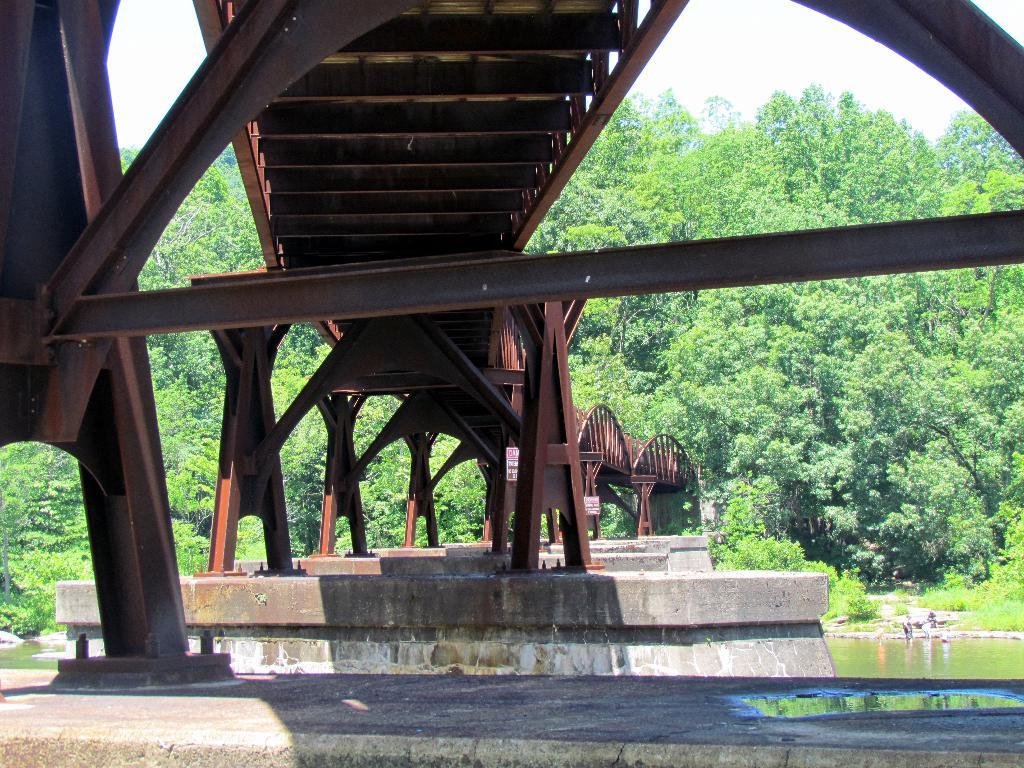What structure is the main subject of the image? There is a bridge in the image. What is the bridge positioned over? The bridge is over water. What can be seen in the background of the image? There are trees visible in the background of the image. What type of berry is growing on the bridge in the image? There are no berries present on the bridge in the image. What type of grain can be seen being harvested in the background of the image? There is no grain harvesting visible in the background of the image; it only features trees. 